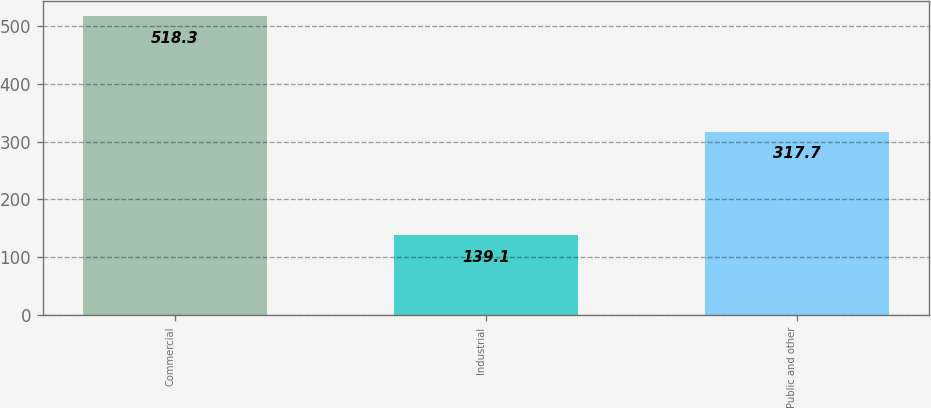Convert chart to OTSL. <chart><loc_0><loc_0><loc_500><loc_500><bar_chart><fcel>Commercial<fcel>Industrial<fcel>Public and other<nl><fcel>518.3<fcel>139.1<fcel>317.7<nl></chart> 